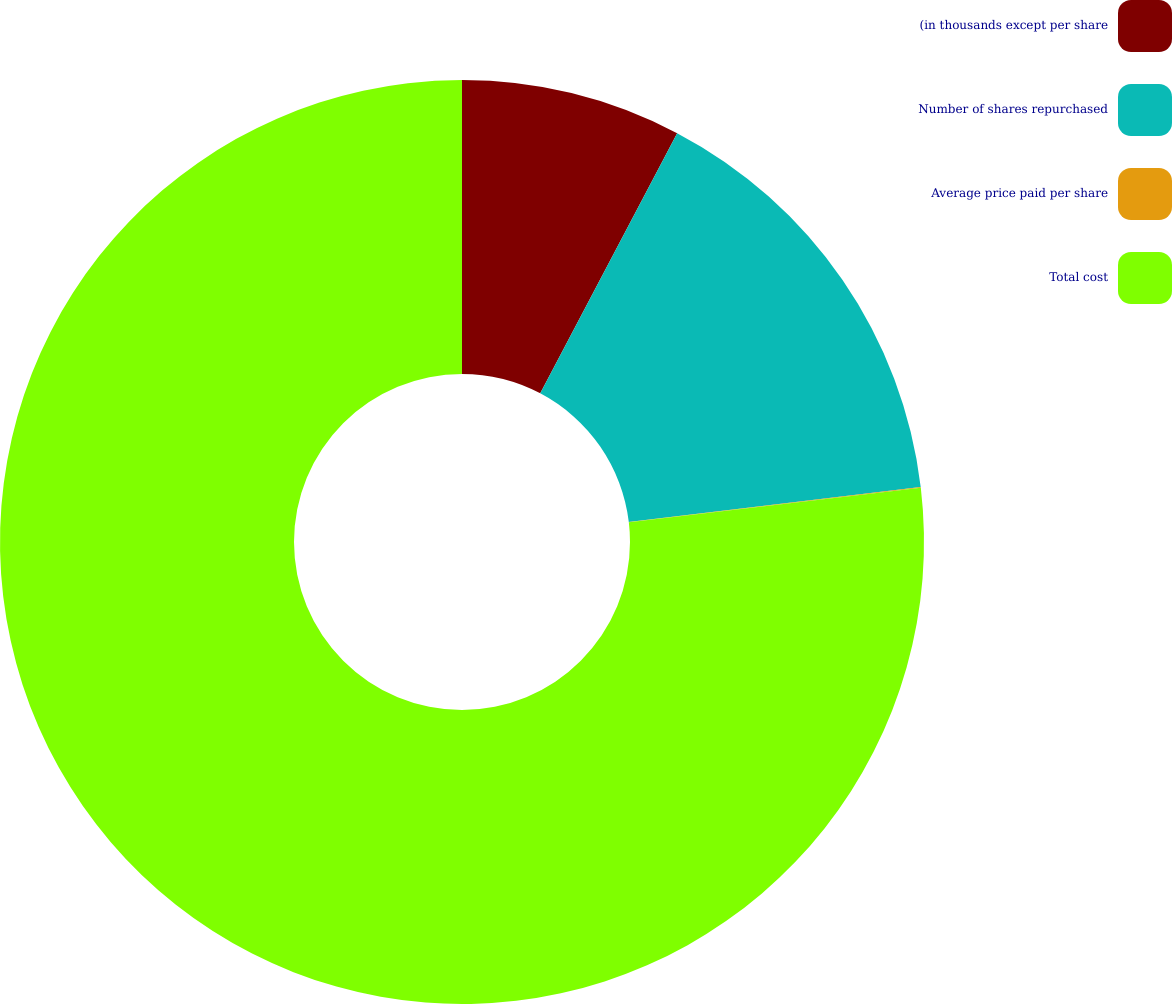Convert chart. <chart><loc_0><loc_0><loc_500><loc_500><pie_chart><fcel>(in thousands except per share<fcel>Number of shares repurchased<fcel>Average price paid per share<fcel>Total cost<nl><fcel>7.71%<fcel>15.39%<fcel>0.03%<fcel>76.87%<nl></chart> 